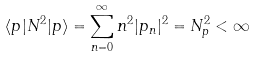<formula> <loc_0><loc_0><loc_500><loc_500>\langle p | N ^ { 2 } | p \rangle = \sum _ { n = 0 } ^ { \infty } n ^ { 2 } | p _ { n } | ^ { 2 } = N _ { p } ^ { 2 } < \infty</formula> 